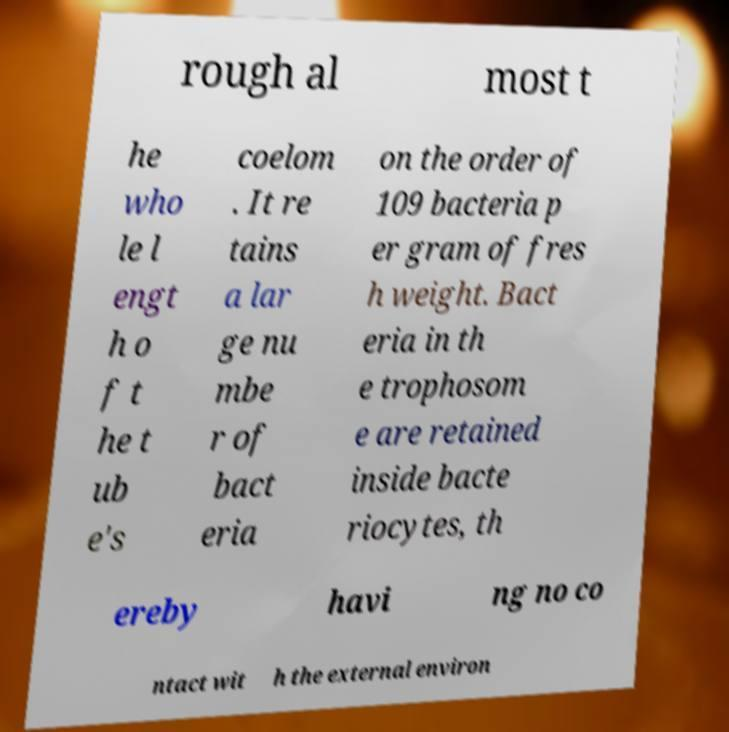There's text embedded in this image that I need extracted. Can you transcribe it verbatim? rough al most t he who le l engt h o f t he t ub e's coelom . It re tains a lar ge nu mbe r of bact eria on the order of 109 bacteria p er gram of fres h weight. Bact eria in th e trophosom e are retained inside bacte riocytes, th ereby havi ng no co ntact wit h the external environ 